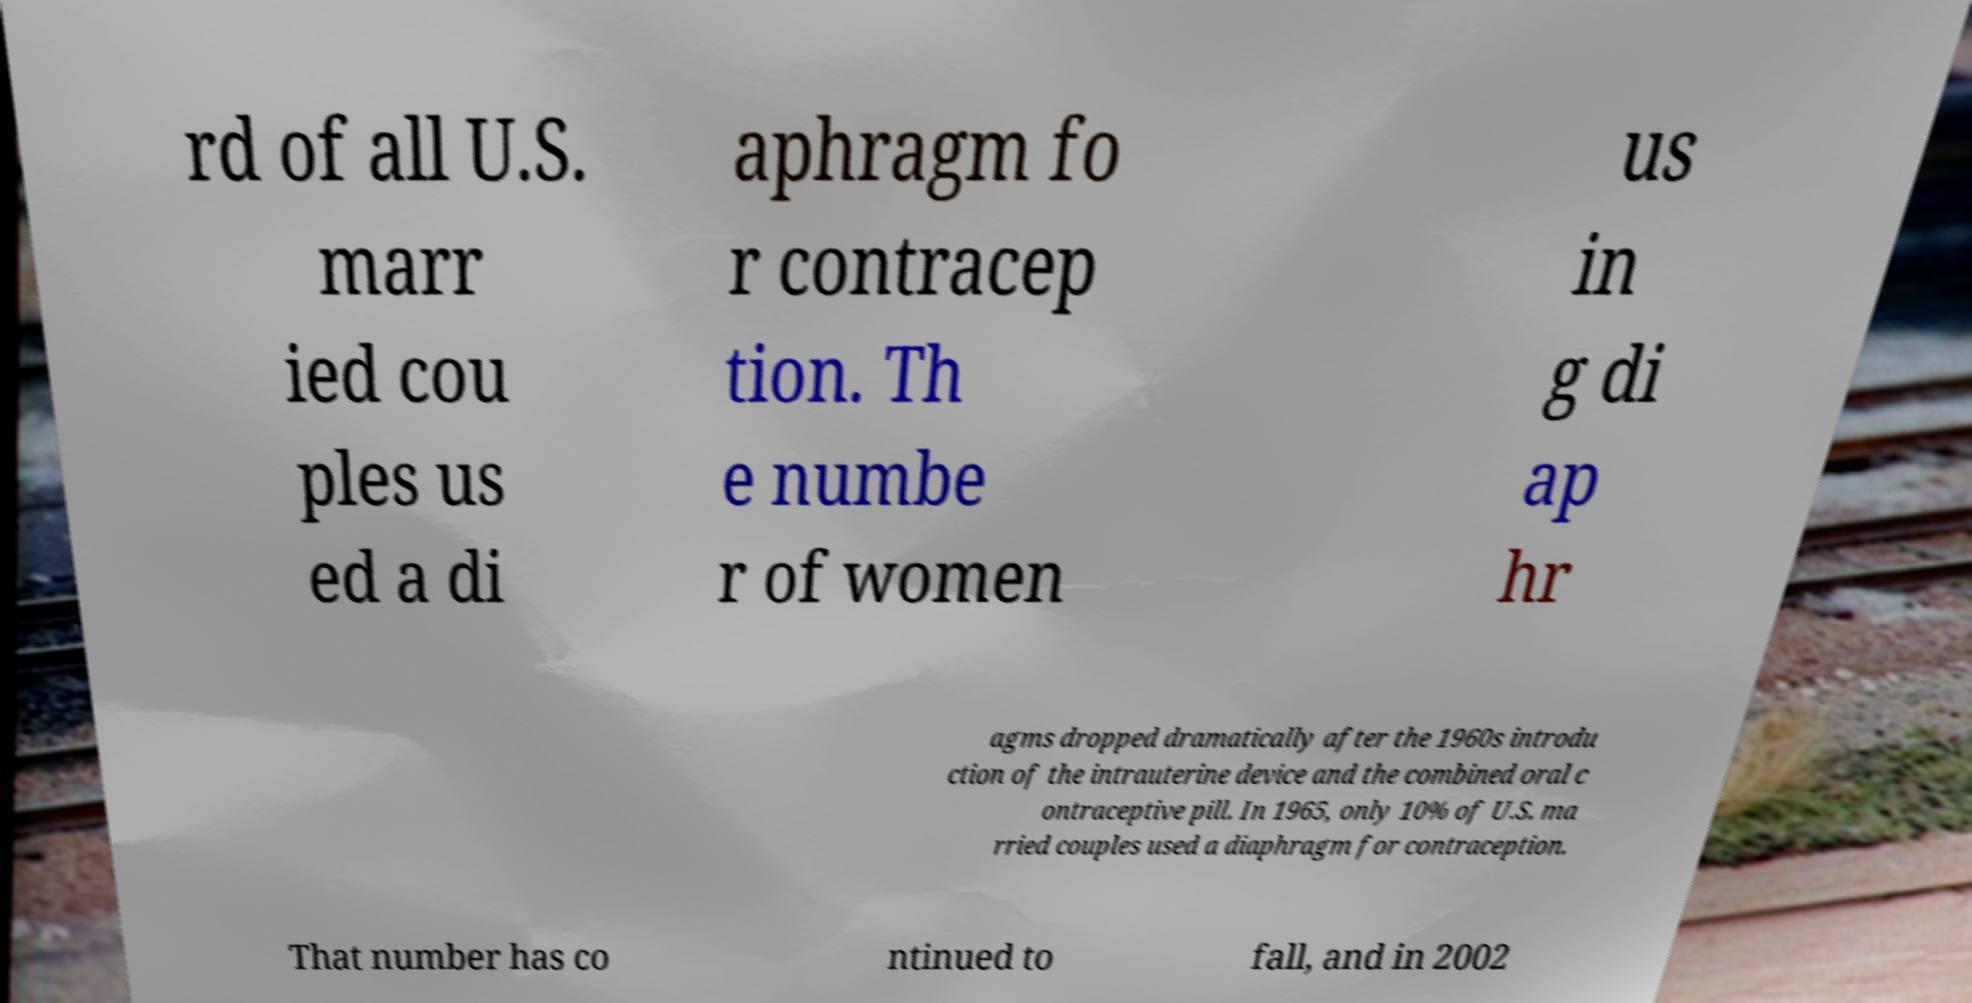Can you read and provide the text displayed in the image?This photo seems to have some interesting text. Can you extract and type it out for me? rd of all U.S. marr ied cou ples us ed a di aphragm fo r contracep tion. Th e numbe r of women us in g di ap hr agms dropped dramatically after the 1960s introdu ction of the intrauterine device and the combined oral c ontraceptive pill. In 1965, only 10% of U.S. ma rried couples used a diaphragm for contraception. That number has co ntinued to fall, and in 2002 